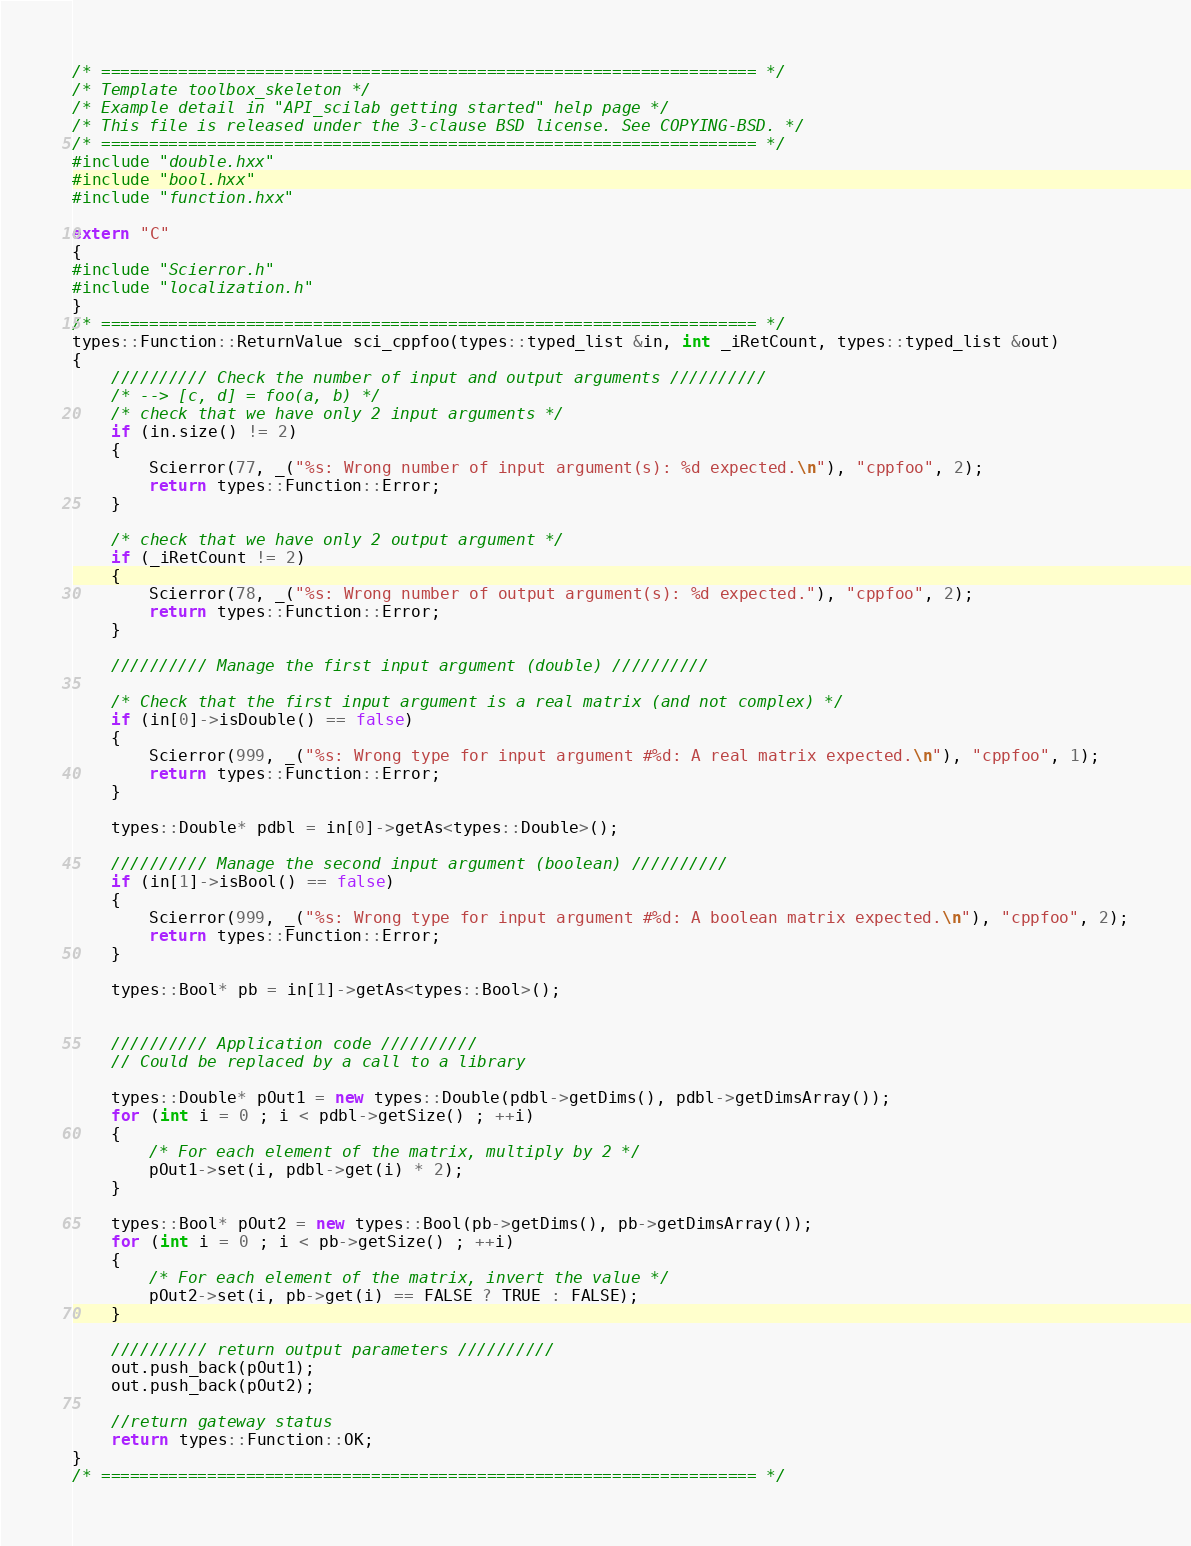<code> <loc_0><loc_0><loc_500><loc_500><_C++_>/* ==================================================================== */
/* Template toolbox_skeleton */
/* Example detail in "API_scilab getting started" help page */
/* This file is released under the 3-clause BSD license. See COPYING-BSD. */
/* ==================================================================== */
#include "double.hxx"
#include "bool.hxx"
#include "function.hxx"

extern "C" 
{
#include "Scierror.h"
#include "localization.h"
}
/* ==================================================================== */
types::Function::ReturnValue sci_cppfoo(types::typed_list &in, int _iRetCount, types::typed_list &out)
{
    ////////// Check the number of input and output arguments //////////
    /* --> [c, d] = foo(a, b) */
    /* check that we have only 2 input arguments */
    if (in.size() != 2)
    {
        Scierror(77, _("%s: Wrong number of input argument(s): %d expected.\n"), "cppfoo", 2);
        return types::Function::Error;
    }

    /* check that we have only 2 output argument */
    if (_iRetCount != 2)
    {
        Scierror(78, _("%s: Wrong number of output argument(s): %d expected."), "cppfoo", 2);
        return types::Function::Error;
    }

    ////////// Manage the first input argument (double) //////////

    /* Check that the first input argument is a real matrix (and not complex) */
    if (in[0]->isDouble() == false)
    {
        Scierror(999, _("%s: Wrong type for input argument #%d: A real matrix expected.\n"), "cppfoo", 1);
        return types::Function::Error;
    }

    types::Double* pdbl = in[0]->getAs<types::Double>();

    ////////// Manage the second input argument (boolean) //////////
    if (in[1]->isBool() == false)
    {
        Scierror(999, _("%s: Wrong type for input argument #%d: A boolean matrix expected.\n"), "cppfoo", 2);
        return types::Function::Error;
    }

    types::Bool* pb = in[1]->getAs<types::Bool>();


    ////////// Application code //////////
    // Could be replaced by a call to a library

    types::Double* pOut1 = new types::Double(pdbl->getDims(), pdbl->getDimsArray());
    for (int i = 0 ; i < pdbl->getSize() ; ++i)
    {
        /* For each element of the matrix, multiply by 2 */
        pOut1->set(i, pdbl->get(i) * 2);
    }

    types::Bool* pOut2 = new types::Bool(pb->getDims(), pb->getDimsArray());
    for (int i = 0 ; i < pb->getSize() ; ++i)
    {
        /* For each element of the matrix, invert the value */
        pOut2->set(i, pb->get(i) == FALSE ? TRUE : FALSE);
    }

    ////////// return output parameters //////////
    out.push_back(pOut1);
    out.push_back(pOut2);

    //return gateway status
    return types::Function::OK;
}
/* ==================================================================== */

</code> 